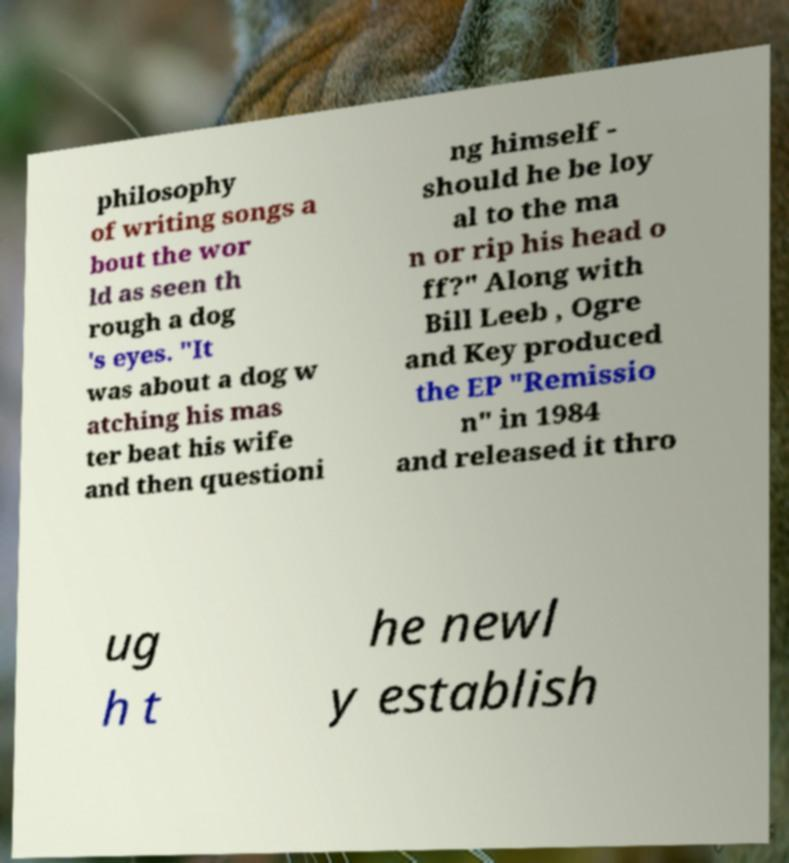Please identify and transcribe the text found in this image. philosophy of writing songs a bout the wor ld as seen th rough a dog 's eyes. "It was about a dog w atching his mas ter beat his wife and then questioni ng himself - should he be loy al to the ma n or rip his head o ff?" Along with Bill Leeb , Ogre and Key produced the EP "Remissio n" in 1984 and released it thro ug h t he newl y establish 